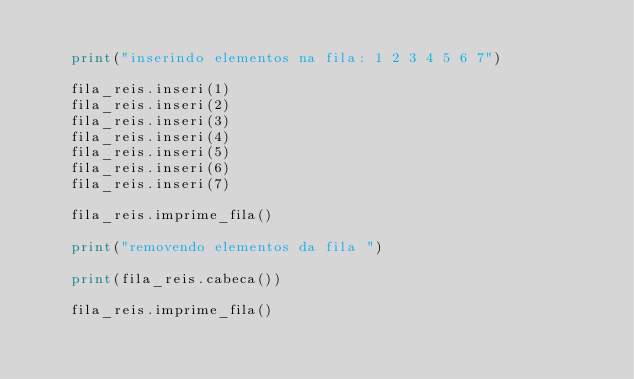<code> <loc_0><loc_0><loc_500><loc_500><_Python_>    
    print("inserindo elementos na fila: 1 2 3 4 5 6 7")
    
    fila_reis.inseri(1)
    fila_reis.inseri(2)
    fila_reis.inseri(3)
    fila_reis.inseri(4)
    fila_reis.inseri(5)
    fila_reis.inseri(6)
    fila_reis.inseri(7)
    
    fila_reis.imprime_fila()
    
    print("removendo elementos da fila ")
    
    print(fila_reis.cabeca())
    
    fila_reis.imprime_fila()</code> 